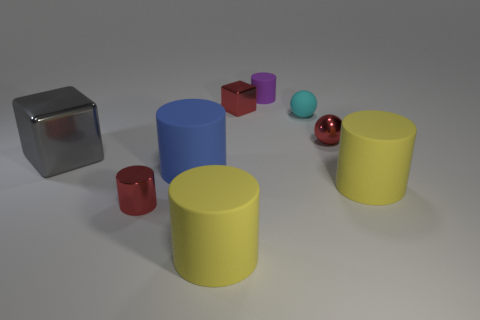There is a big gray object; what shape is it?
Your answer should be compact. Cube. Is the number of red things that are left of the red metallic sphere greater than the number of big blue matte cylinders right of the big blue rubber thing?
Offer a very short reply. Yes. Does the metal object that is in front of the big block have the same color as the tiny metallic object that is right of the tiny purple thing?
Keep it short and to the point. Yes. The matte thing that is the same size as the rubber sphere is what shape?
Keep it short and to the point. Cylinder. Are there any blue things of the same shape as the gray thing?
Make the answer very short. No. Is the small red thing on the right side of the tiny rubber cylinder made of the same material as the block right of the large blue matte cylinder?
Offer a terse response. Yes. What number of small purple cylinders have the same material as the gray block?
Offer a terse response. 0. What is the color of the big metallic thing?
Give a very brief answer. Gray. Does the yellow object that is in front of the small red metal cylinder have the same shape as the red shiny object that is in front of the large metallic block?
Offer a terse response. Yes. What color is the metal cube left of the small red cylinder?
Offer a terse response. Gray. 